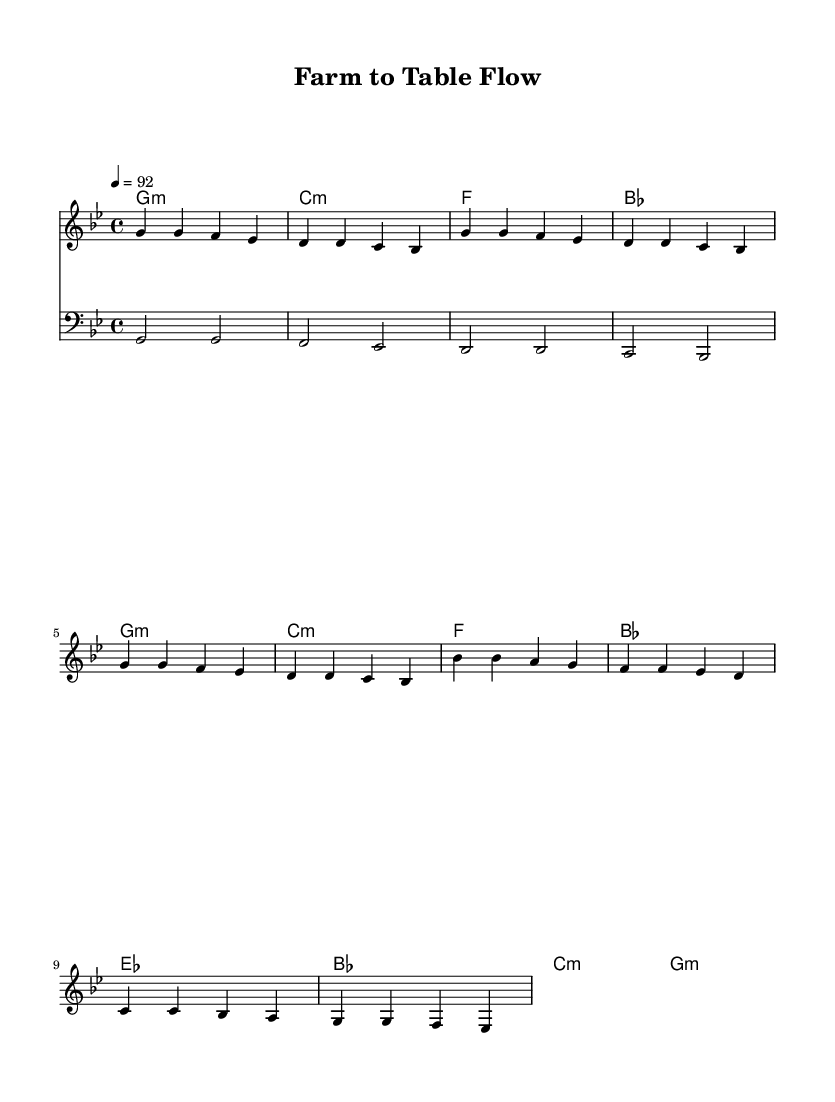What is the key signature of this music? The key signature is G minor, which is indicated by two flats (B flat and E flat) in the key signature at the beginning of the staff.
Answer: G minor What is the time signature of this music? The time signature is 4/4, as shown near the beginning of the score, indicating four beats in each measure and that a quarter note receives one beat.
Answer: 4/4 What is the tempo marking for this music? The tempo marking shows "4 = 92," which indicates the speed at which the piece should be played, with quarter notes counted at 92 beats per minute.
Answer: 92 How many measures are in the verse section? There are four measures in the verse, as indicated by the repeated melodic line that spans from the first g' to the last bes in that section before the chorus.
Answer: 4 What type of harmony is used in the chorus? The harmony in the chorus section primarily uses E flat major, B flat major, C minor, and G minor, which contributes to the overall emotional tone of the piece and emphasizes the transitions in the lyrics.
Answer: E flat major, B flat major, C minor, G minor What is the primary rhythmic pattern in the melody? The primary rhythmic pattern in the melody consists predominantly of quarter notes, which are standard in rap music, helping to maintain a steady and engaging flow throughout the piece.
Answer: Quarter notes What is the overall theme expressed in this rap? The overall theme revolves around the concept of using fresh, local ingredients in cooking, which is reflected in the lyrics and the title "Farm to Table Flow."
Answer: Fresh, local ingredients 